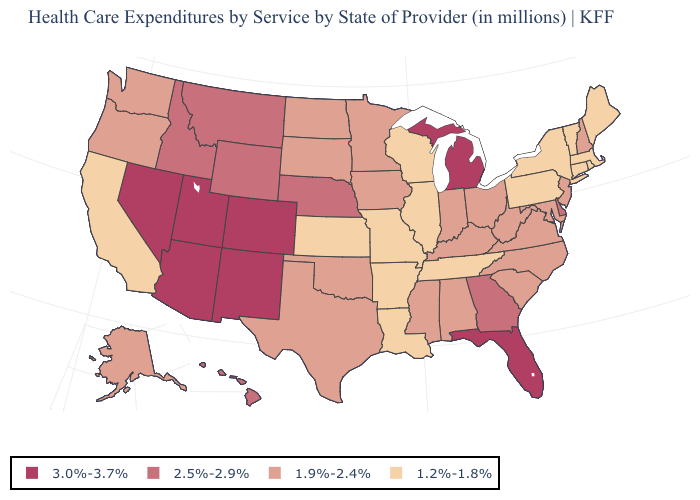How many symbols are there in the legend?
Concise answer only. 4. What is the value of Arizona?
Give a very brief answer. 3.0%-3.7%. Among the states that border Virginia , which have the highest value?
Short answer required. Kentucky, Maryland, North Carolina, West Virginia. What is the value of Wisconsin?
Quick response, please. 1.2%-1.8%. What is the lowest value in states that border Texas?
Short answer required. 1.2%-1.8%. Does Virginia have a lower value than Arizona?
Quick response, please. Yes. Does the map have missing data?
Concise answer only. No. Does South Carolina have the highest value in the South?
Answer briefly. No. What is the value of Arkansas?
Short answer required. 1.2%-1.8%. What is the value of Florida?
Be succinct. 3.0%-3.7%. Which states hav the highest value in the MidWest?
Quick response, please. Michigan. What is the value of Oregon?
Be succinct. 1.9%-2.4%. What is the value of Alaska?
Concise answer only. 1.9%-2.4%. Name the states that have a value in the range 2.5%-2.9%?
Be succinct. Delaware, Georgia, Hawaii, Idaho, Montana, Nebraska, Wyoming. What is the highest value in the USA?
Quick response, please. 3.0%-3.7%. 